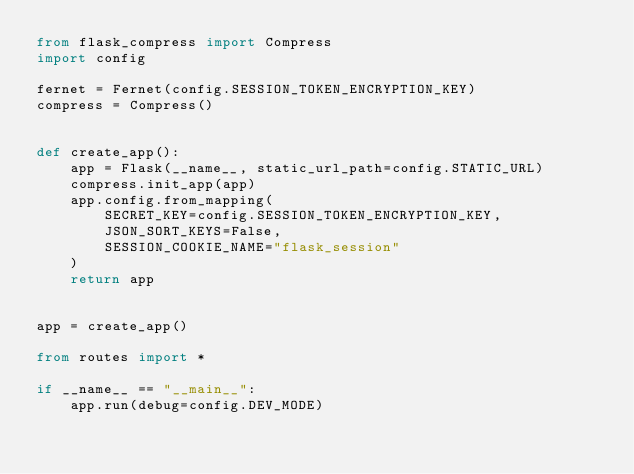Convert code to text. <code><loc_0><loc_0><loc_500><loc_500><_Python_>from flask_compress import Compress
import config

fernet = Fernet(config.SESSION_TOKEN_ENCRYPTION_KEY)
compress = Compress()


def create_app():
    app = Flask(__name__, static_url_path=config.STATIC_URL)
    compress.init_app(app)
    app.config.from_mapping(
        SECRET_KEY=config.SESSION_TOKEN_ENCRYPTION_KEY,
        JSON_SORT_KEYS=False,
        SESSION_COOKIE_NAME="flask_session"
    )
    return app


app = create_app()

from routes import *

if __name__ == "__main__":
    app.run(debug=config.DEV_MODE)
</code> 